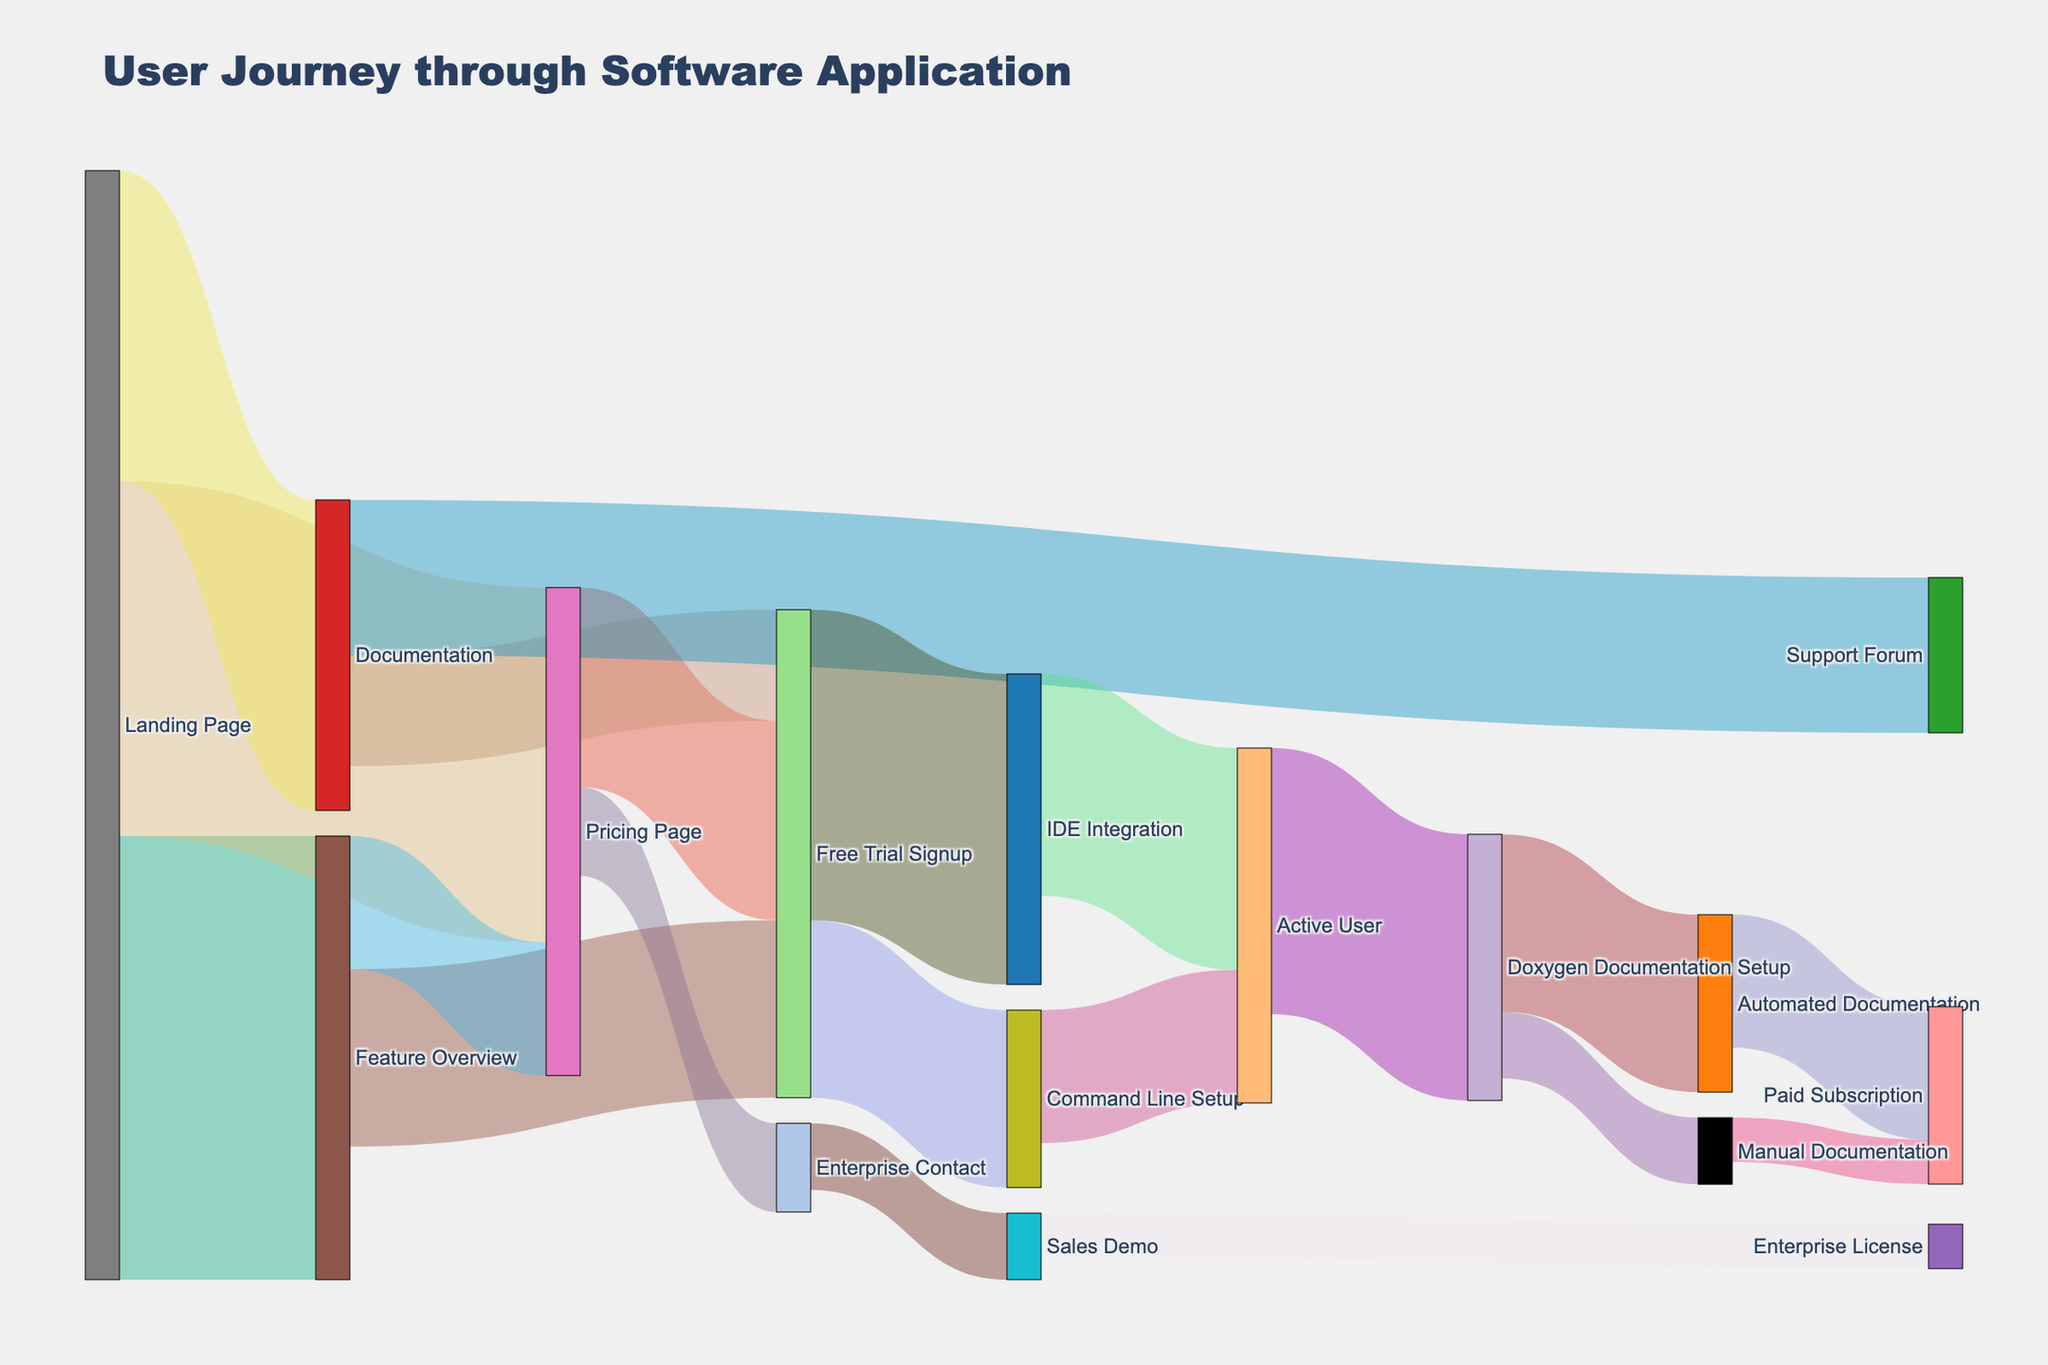What is the title of the Sankey diagram? The title of the Sankey diagram is displayed at the top of the figure. It summarizes the overall purpose of the diagram.
Answer: User Journey through Software Application Which step has the highest initial value from the Landing Page? Inspect the links originating from the Landing Page and compare their values. Feature Overview has the highest value of 1000 compared to Pricing Page (800) and Documentation (700).
Answer: Feature Overview How many users signed up for a free trial from Feature Overview and Pricing Page combined? Adding the values of users who signed up for a free trial from Feature Overview (400) and Pricing Page (450) gives their combined total. 400 + 450 = 850.
Answer: 850 What percentage of users move from Free Trial Signup to IDE Integration? Out of the total users signing up for the free trial (400 from Feature Overview + 450 from Pricing Page + 250 from Documentation = 1100), a total of 700 go to IDE Integration. The percentage is (700 / 1100) * 100 = 63.64%.
Answer: 63.64% Which conversion is more popular: Free Trial Signup to IDE Integration or Command Line Setup? Comparing the values from Free Trial Signup, 700 go to IDE Integration and 400 go to Command Line Setup. IDE Integration has a higher value.
Answer: IDE Integration From the node Automated Documentation, how many users eventually convert to a Paid Subscription? The total number is found by adding the paths from Automated Documentation leading to Paid Subscription, which is 300.
Answer: 300 What is the total number of users that end up as Active Users? Summing the users coming to Active User from IDE Integration (500) and Command Line Setup (300) gives the total. 500 + 300 = 800.
Answer: 800 Compare the number of users that get Automated Documentation to those who get Manual Documentation. From Doxygen Documentation Setup, 400 users go to Automated Documentation and 150 to Manual Documentation. Automated Documentation has more users.
Answer: Automated Documentation How many users convert from Sales Demo to Enterprise License? The path shows the value for this conversion, which is directly given as 100 users.
Answer: 100 What proportion of users from Documentation look at Support Forum compared to those signing up for a Free Trial? Inspecting the paths from Documentation, 350 users go to the Support Forum, and 250 go to Free Trial Signup. The proportion is 350 / 250 = 1.4.
Answer: 1.4 